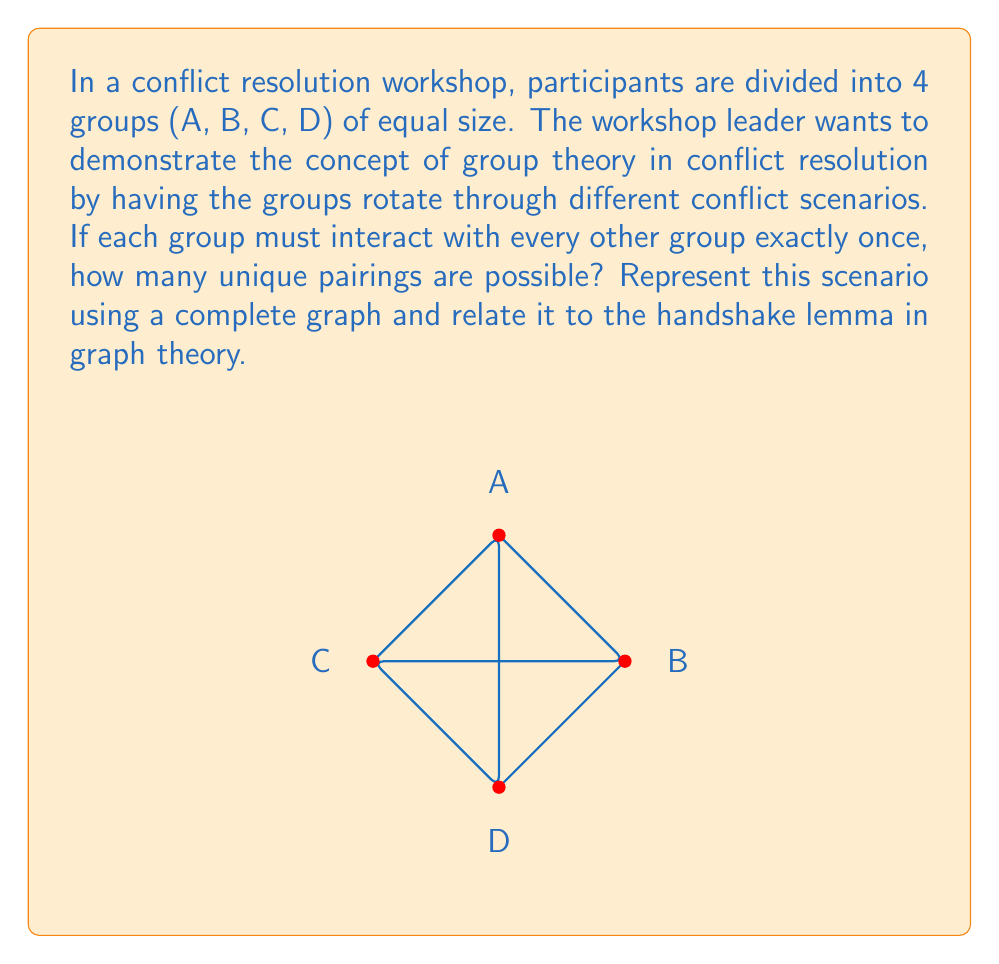Solve this math problem. Let's approach this step-by-step:

1) First, we need to understand that this problem is equivalent to finding the number of edges in a complete graph with 4 vertices (each vertex representing a group).

2) In group theory, this relates to the concept of a symmetric group $S_4$, where each pairing represents a transposition.

3) The handshake lemma in graph theory states that the sum of the degrees of all vertices in a graph is equal to twice the number of edges. In a complete graph, each vertex is connected to every other vertex.

4) For a complete graph with n vertices, each vertex has a degree of (n-1). Therefore, the total degree sum is n(n-1).

5) According to the handshake lemma:
   $$\text{Total degree sum} = 2 \times \text{number of edges}$$

6) In our case, n = 4, so:
   $$4(4-1) = 2 \times \text{number of edges}$$
   $$12 = 2 \times \text{number of edges}$$

7) Solving for the number of edges:
   $$\text{Number of edges} = \frac{12}{2} = 6$$

8) This result can also be obtained using the combination formula:
   $$\binom{4}{2} = \frac{4!}{2!(4-2)!} = \frac{4 \times 3}{2 \times 1} = 6$$

9) In the context of conflict resolution, each of these 6 pairings represents a unique interaction between two groups, allowing for diverse perspectives and strategies to be explored.
Answer: 6 unique pairings 